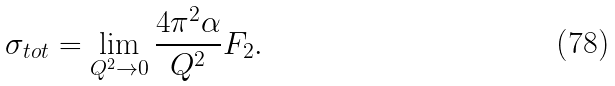Convert formula to latex. <formula><loc_0><loc_0><loc_500><loc_500>\sigma _ { t o t } = \lim _ { Q ^ { 2 } \rightarrow 0 } \frac { 4 \pi ^ { 2 } \alpha } { Q ^ { 2 } } F _ { 2 } .</formula> 